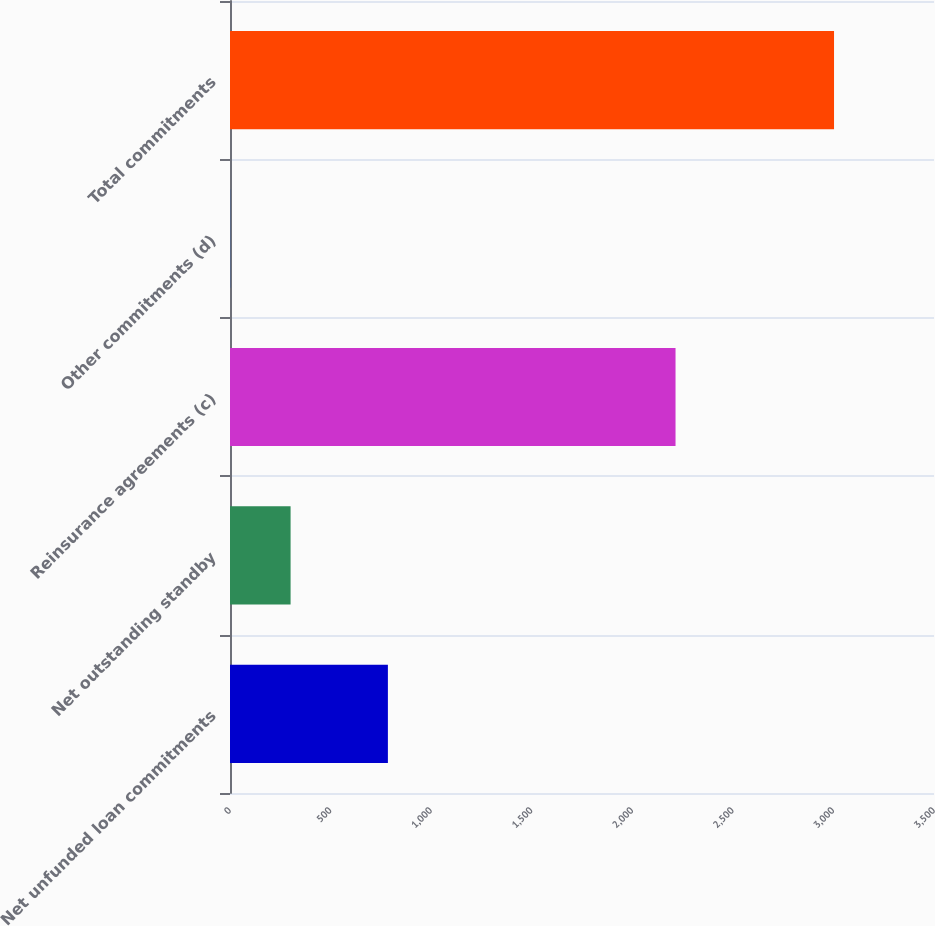<chart> <loc_0><loc_0><loc_500><loc_500><bar_chart><fcel>Net unfunded loan commitments<fcel>Net outstanding standby<fcel>Reinsurance agreements (c)<fcel>Other commitments (d)<fcel>Total commitments<nl><fcel>785<fcel>301.2<fcel>2215<fcel>1<fcel>3003<nl></chart> 